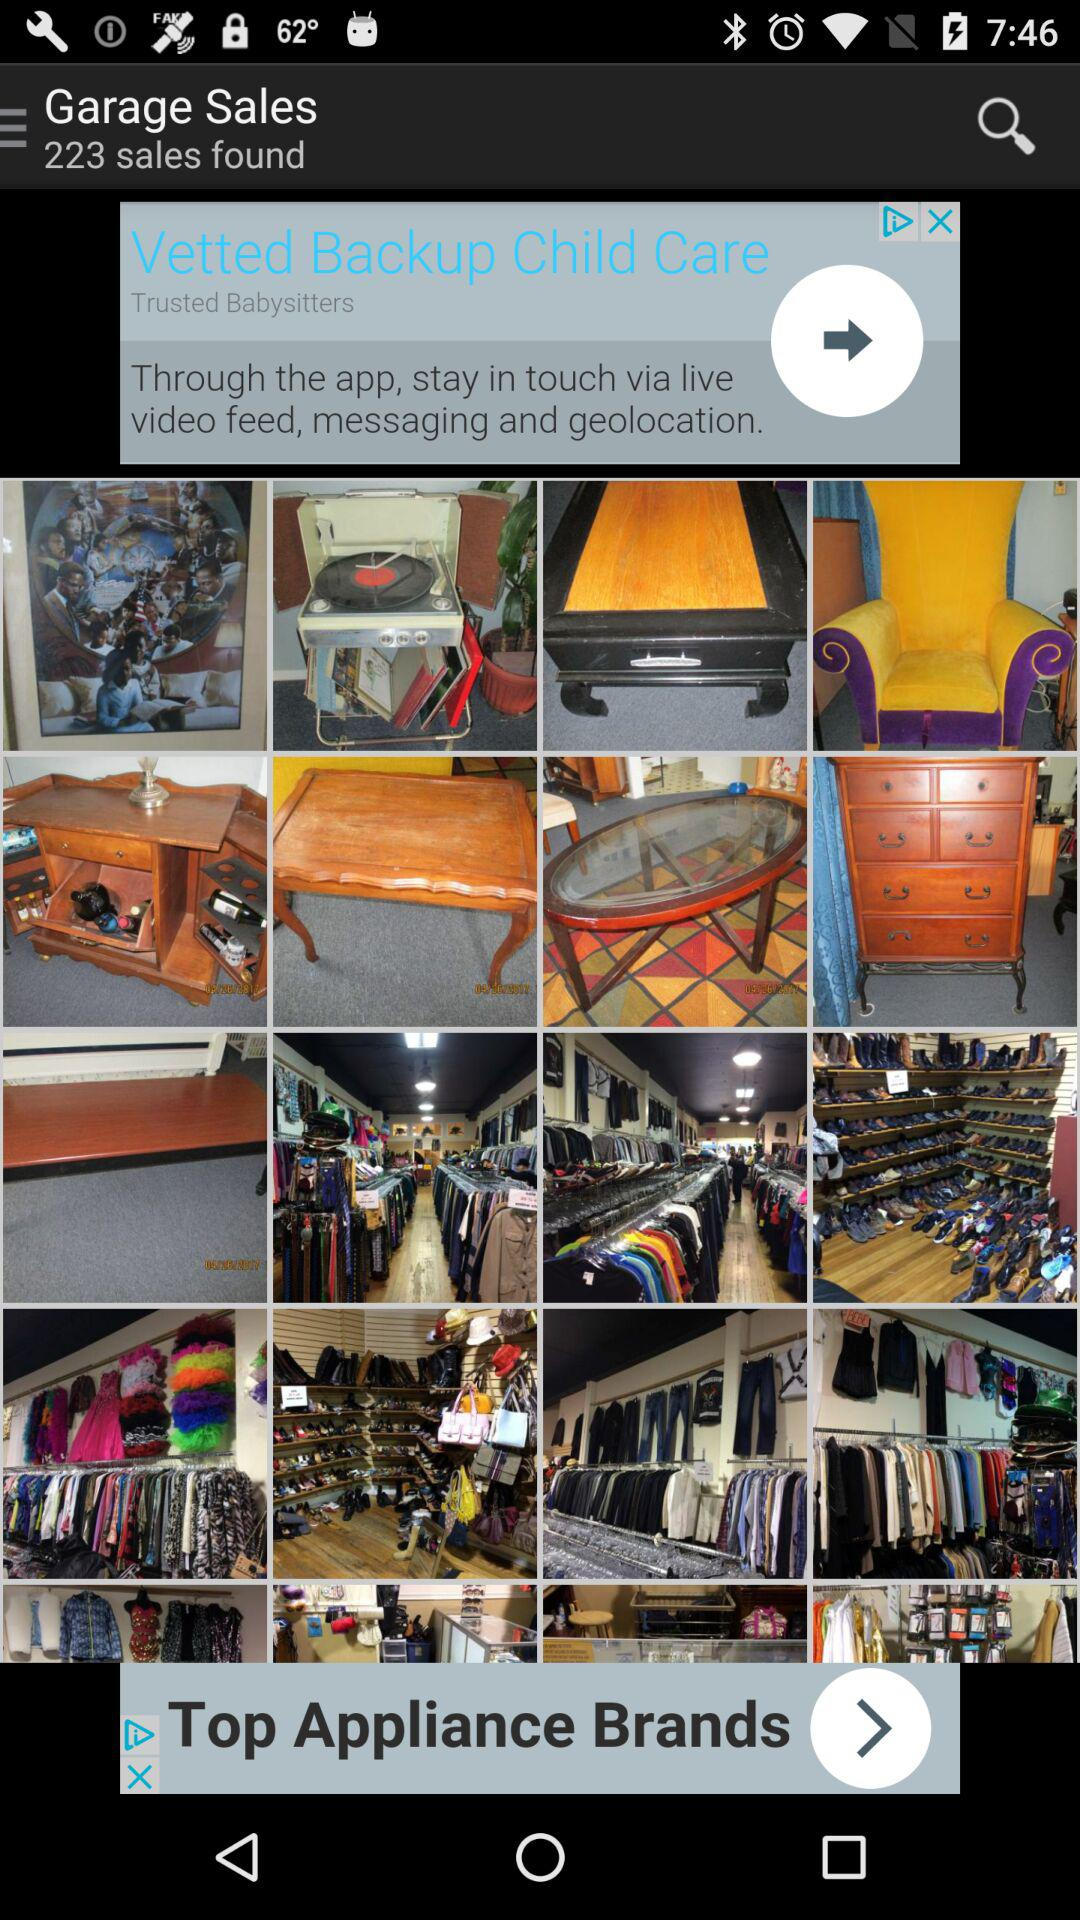How many sales are found? There are 223 sales found. 